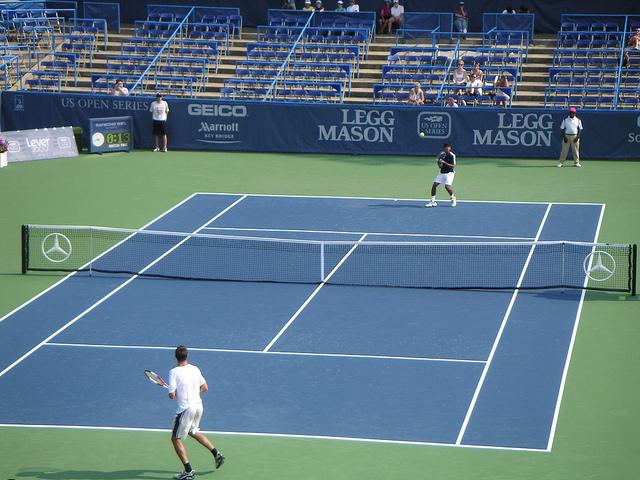What company is sponsoring this game?
Be succinct. Legg mason. Is this a well attended tennis match?
Answer briefly. No. How many people are sitting in the audience?
Concise answer only. 10. Does it look nice out?
Short answer required. Yes. 